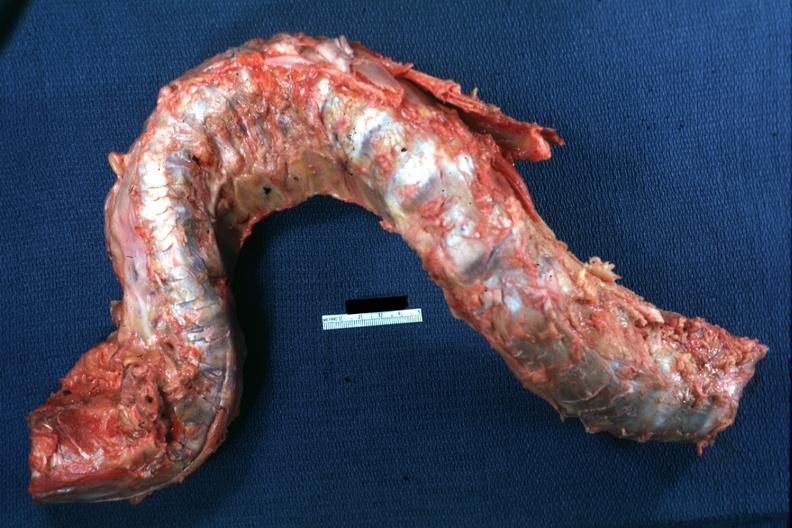what deformed?
Answer the question using a single word or phrase. Spinal column 